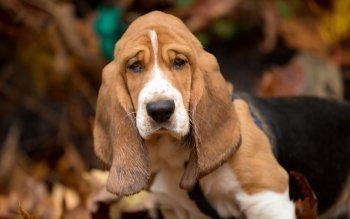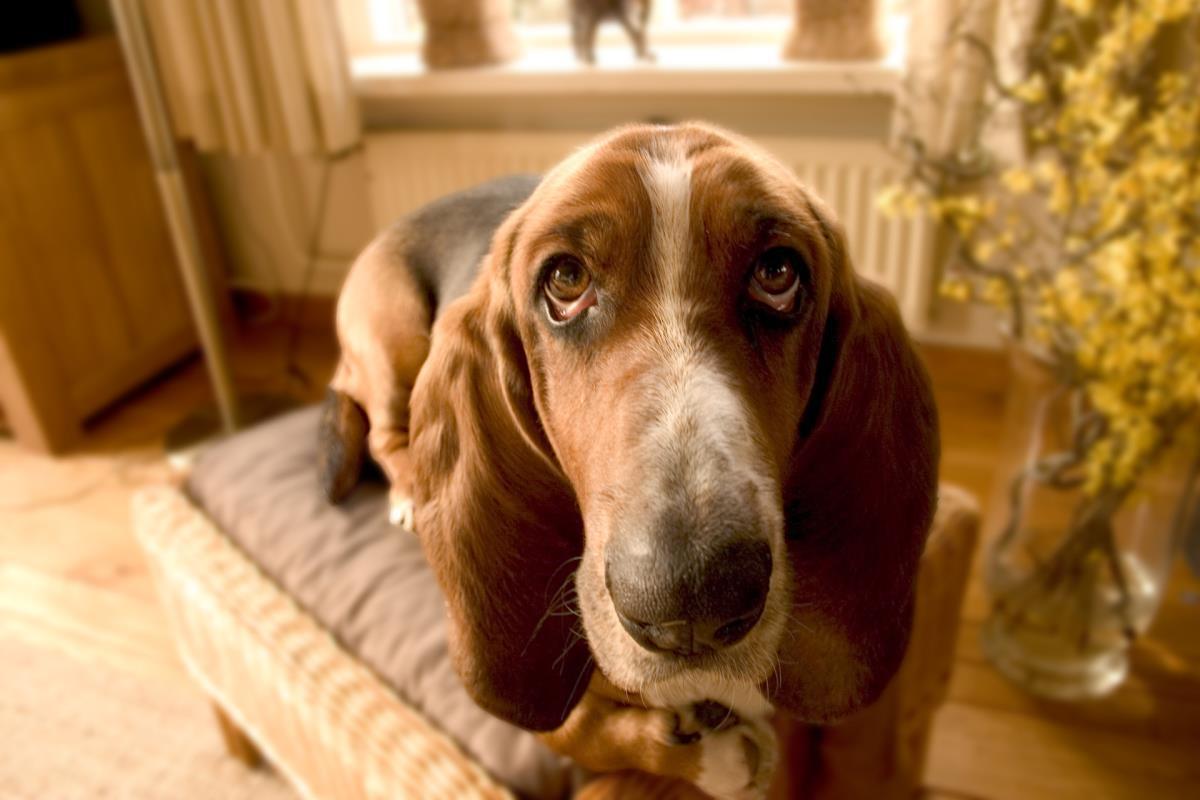The first image is the image on the left, the second image is the image on the right. Given the left and right images, does the statement "One image features a basset pup on a wood plank deck outdoors." hold true? Answer yes or no. No. 